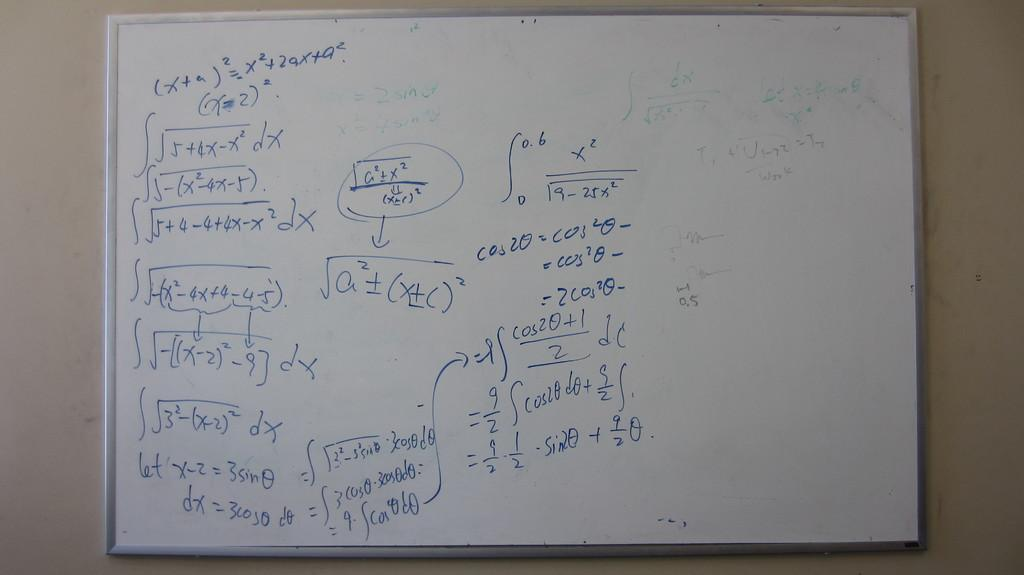<image>
Summarize the visual content of the image. A whiteboard shows trigonometric functions including sine and cosine. 